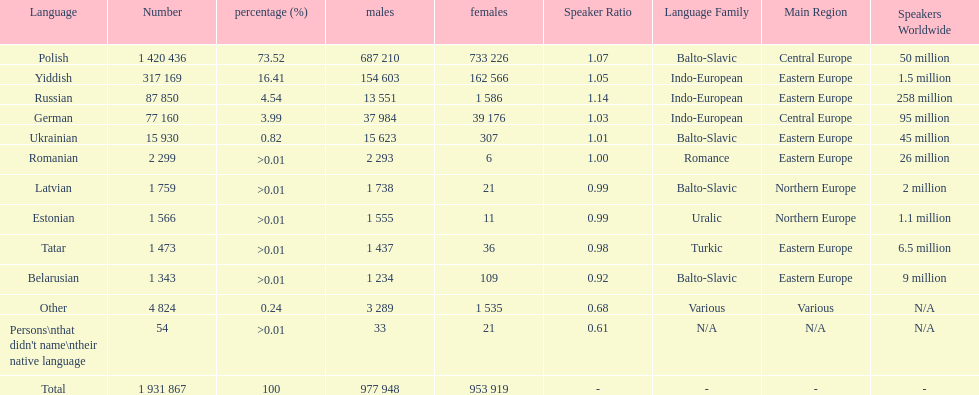What was the top language from the one's whose percentage was >0.01 Romanian. Write the full table. {'header': ['Language', 'Number', 'percentage (%)', 'males', 'females', 'Speaker Ratio', 'Language Family', 'Main Region', 'Speakers Worldwide'], 'rows': [['Polish', '1 420 436', '73.52', '687 210', '733 226', '1.07', 'Balto-Slavic', 'Central Europe', '50 million'], ['Yiddish', '317 169', '16.41', '154 603', '162 566', '1.05', 'Indo-European', 'Eastern Europe', '1.5 million'], ['Russian', '87 850', '4.54', '13 551', '1 586', '1.14', 'Indo-European', 'Eastern Europe', '258 million'], ['German', '77 160', '3.99', '37 984', '39 176', '1.03', 'Indo-European', 'Central Europe', '95 million'], ['Ukrainian', '15 930', '0.82', '15 623', '307', '1.01', 'Balto-Slavic', 'Eastern Europe', '45 million'], ['Romanian', '2 299', '>0.01', '2 293', '6', '1.00', 'Romance', 'Eastern Europe', '26 million'], ['Latvian', '1 759', '>0.01', '1 738', '21', '0.99', 'Balto-Slavic', 'Northern Europe', '2 million'], ['Estonian', '1 566', '>0.01', '1 555', '11', '0.99', 'Uralic', 'Northern Europe', '1.1 million'], ['Tatar', '1 473', '>0.01', '1 437', '36', '0.98', 'Turkic', 'Eastern Europe', '6.5 million'], ['Belarusian', '1 343', '>0.01', '1 234', '109', '0.92', 'Balto-Slavic', 'Eastern Europe', '9 million'], ['Other', '4 824', '0.24', '3 289', '1 535', '0.68', 'Various', 'Various', 'N/A'], ["Persons\\nthat didn't name\\ntheir native language", '54', '>0.01', '33', '21', '0.61', 'N/A', 'N/A', 'N/A'], ['Total', '1 931 867', '100', '977 948', '953 919', '-', '-', '-', '-']]} 